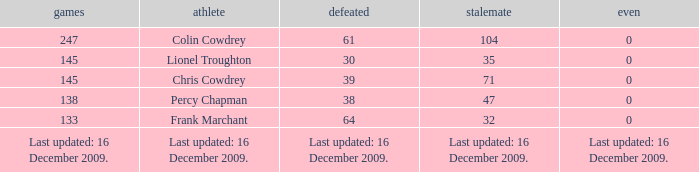I want to know the drawn that has a tie of 0 and the player is chris cowdrey 71.0. 